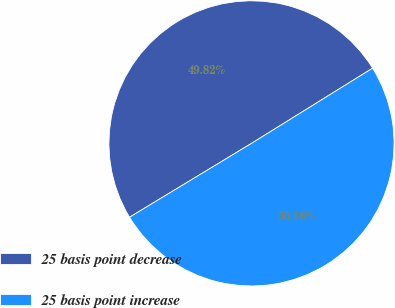Convert chart. <chart><loc_0><loc_0><loc_500><loc_500><pie_chart><fcel>25 basis point decrease<fcel>25 basis point increase<nl><fcel>49.82%<fcel>50.18%<nl></chart> 